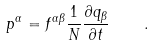<formula> <loc_0><loc_0><loc_500><loc_500>p ^ { \alpha } = f ^ { \alpha \beta } \frac { 1 } { N } \frac { \partial q _ { \beta } } { \partial t } \quad .</formula> 